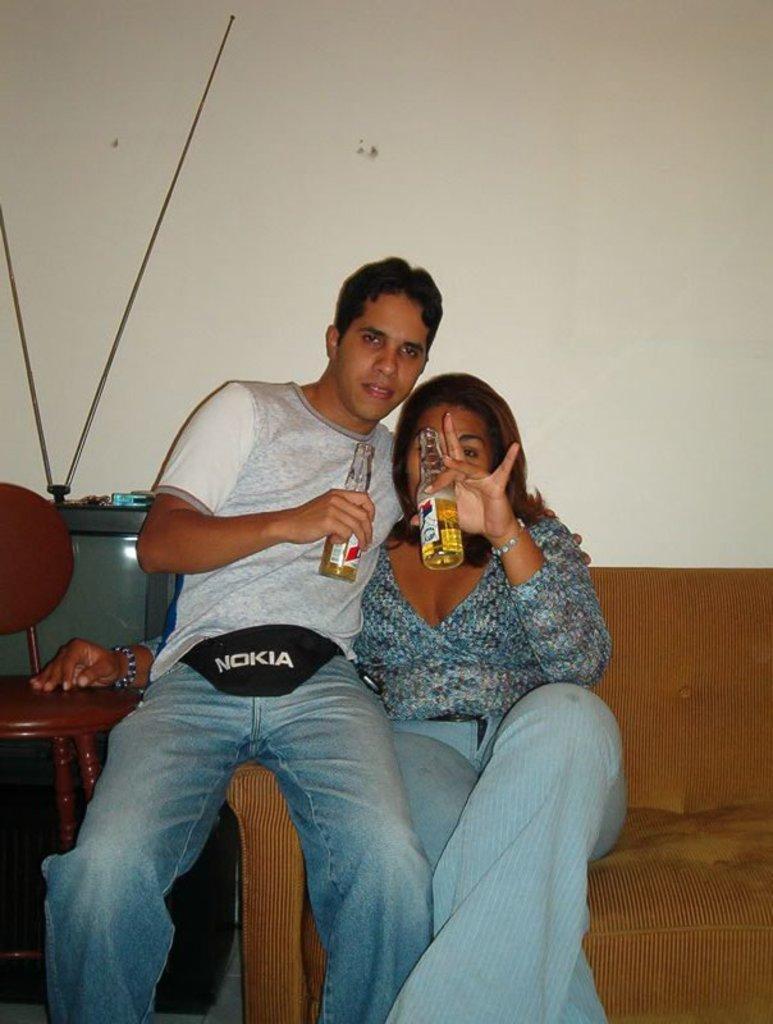Can you describe this image briefly? In this picture I can see a man and a woman holding the bottle. I can see sofa. I can see television. I can see sitting chair. 